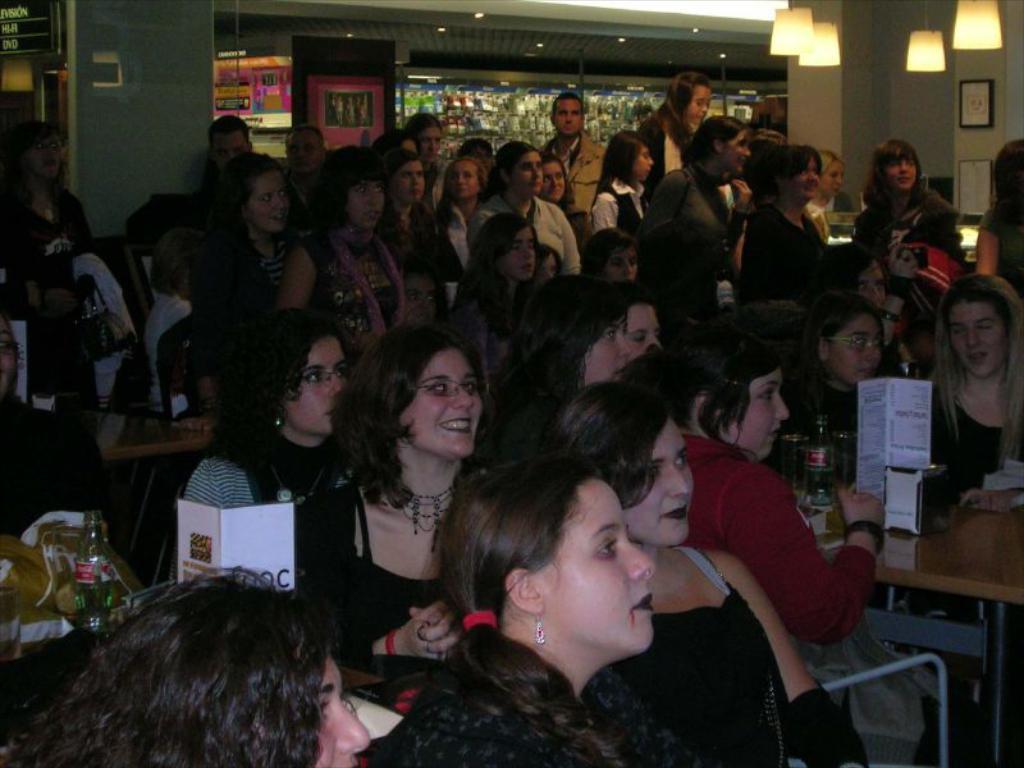Can you describe this image briefly? As we can see in the picture that there are many people some of them are standing and some of them are sitting. There is a table and chair, on table the bottles are placed. This is a photo frame, lamp. 